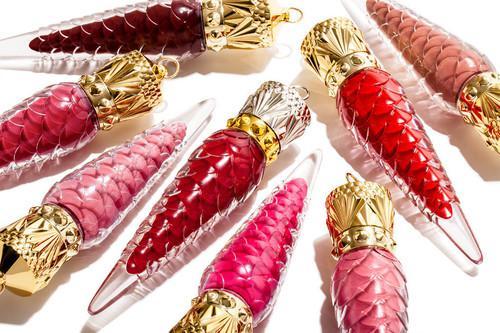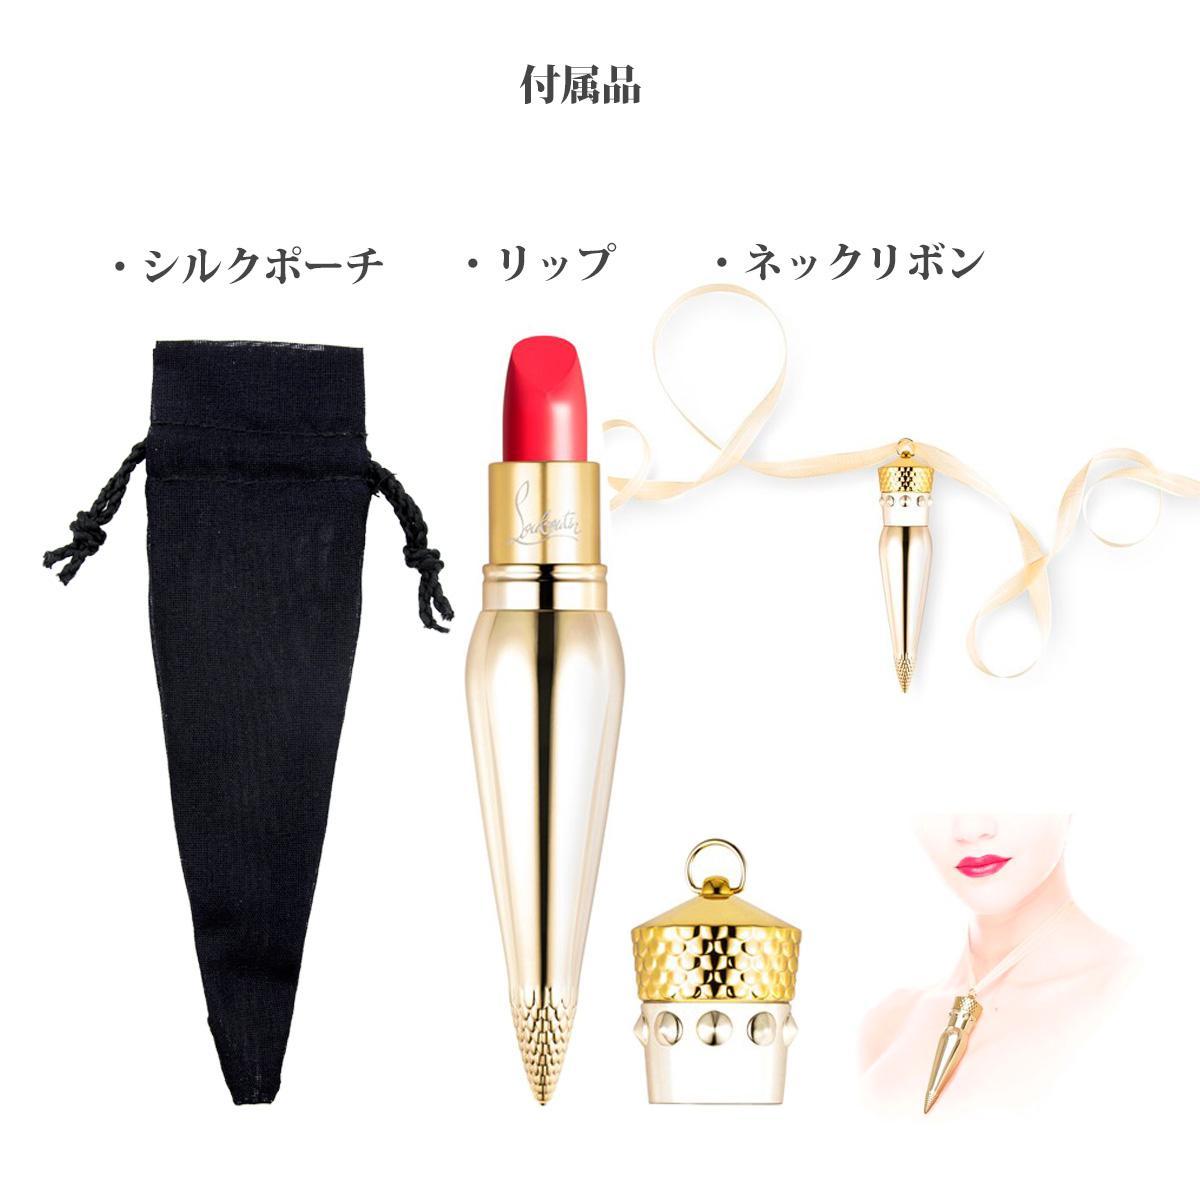The first image is the image on the left, the second image is the image on the right. Considering the images on both sides, is "An image shows at least eight ornament-shaped lipsticks in various shades." valid? Answer yes or no. Yes. The first image is the image on the left, the second image is the image on the right. For the images displayed, is the sentence "There are at least five cone shaped lipstick containers in the image on the left." factually correct? Answer yes or no. Yes. 